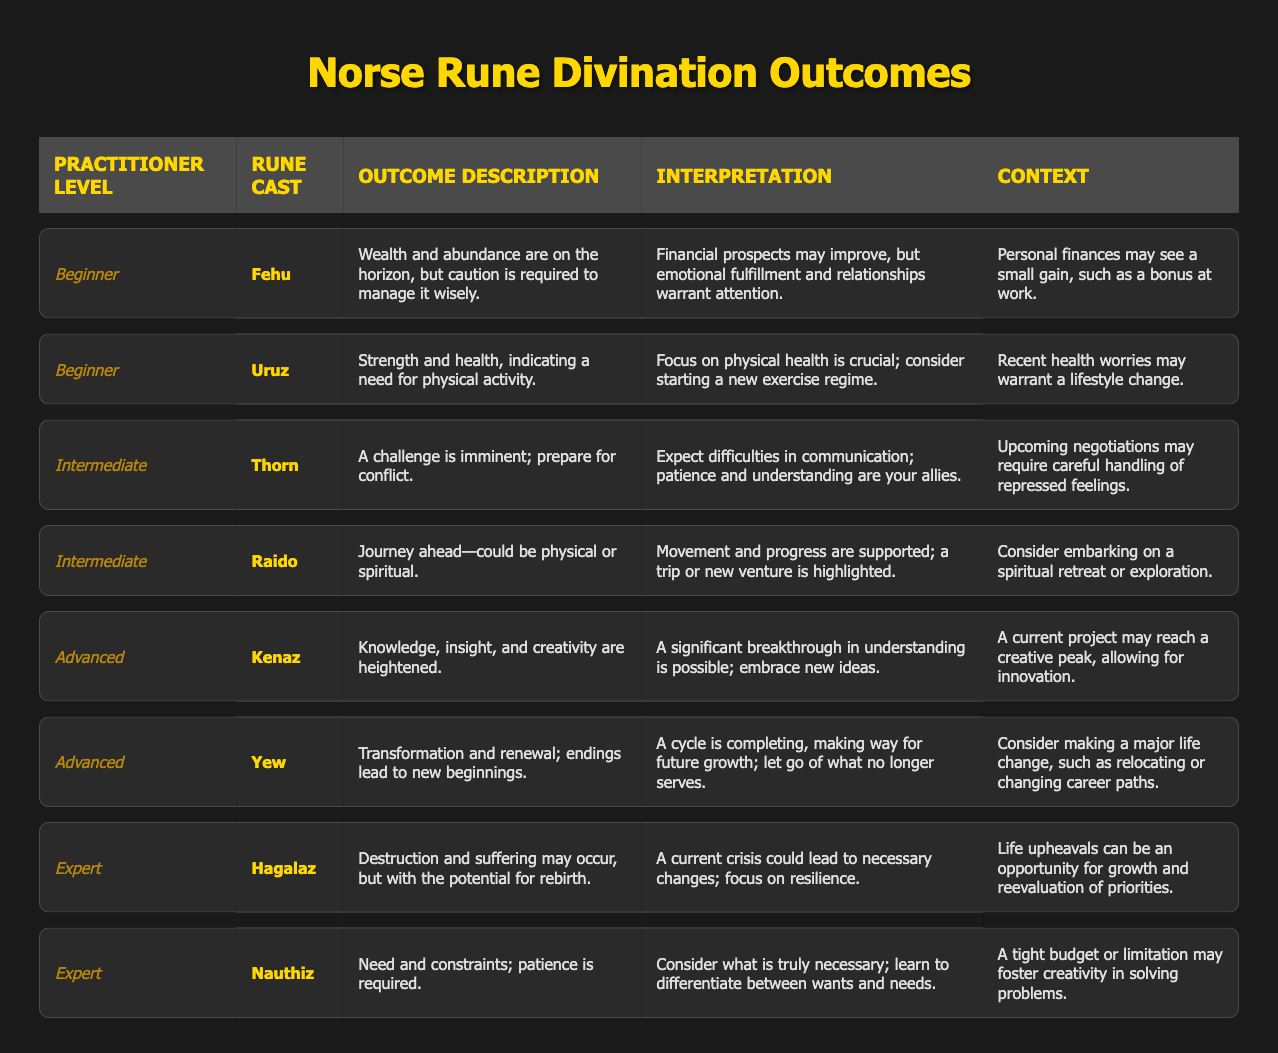What rune did the Advanced practitioner cast to indicate transformation and renewal? The table shows that the rune cast by the Advanced practitioner related to transformation and renewal is "Yew."
Answer: Yew What is the context for the Beginner rune cast "Fehu"? In the table, the context for the Beginner rune cast "Fehu" is about personal finances potentially seeing a small gain, such as a bonus at work.
Answer: Bonus at work Which outcome indicates a need for patience among Expert practitioners? Looking at the table, the Expert rune cast "Nauthiz" indicates a need for patience due to constraints and necessity.
Answer: Nauthiz How many Intermediate outcomes suggest challenges or conflicts? There are two outcomes listed for Intermediate practitioners: "Thorn" and "Raido," but only "Thorn" suggests challenges or conflicts.
Answer: 1 Is the interpretation of the rune "Uruz" more concerned with physical health or emotional fulfillment? The interpretation for the rune "Uruz" emphasizes focusing on physical health, thus answering our question regarding health.
Answer: Physical health For which competency level is the rune "Kenaz" relevant, and what is its outcome description? The table indicates that the rune "Kenaz" is relevant to Advanced practitioners and its outcome description highlights heightened knowledge, insight, and creativity.
Answer: Advanced; Knowledge, insight, and creativity are heightened What are the main differences between the outcomes for Intermediate and Expert levels? The Intermediate outcomes focus on challenges (Thorn) and journeys (Raido), while Expert outcomes revolve around destruction with potential for rebirth (Hagalaz) and constraints needing patience (Nauthiz). This shows a shift from preparation to facing crises.
Answer: Intermediate focuses on preparation, Expert on crises Which rune cast suggests embarking on a journey, and what type of journey is indicated? The rune cast "Raido" suggests that a journey is ahead, which could be either physical or spiritual according to the table.
Answer: Raido; Physical or spiritual What is the primary theme for the Advanced practitioner levels based on the rune outcomes? The primary theme for Advanced practitioners based on the rune outcomes revolves around creativity, knowledge, and transformation, as indicated by the runes "Kenaz" and "Yew."
Answer: Creativity and transformation How does the outcome of the rune "Hagalaz" relate to resilience? The table describes that "Hagalaz" indicates destruction but notes that a current crisis could lead to necessary changes, thereby emphasizing the importance of resilience in such times.
Answer: Resilience is crucial in crises 